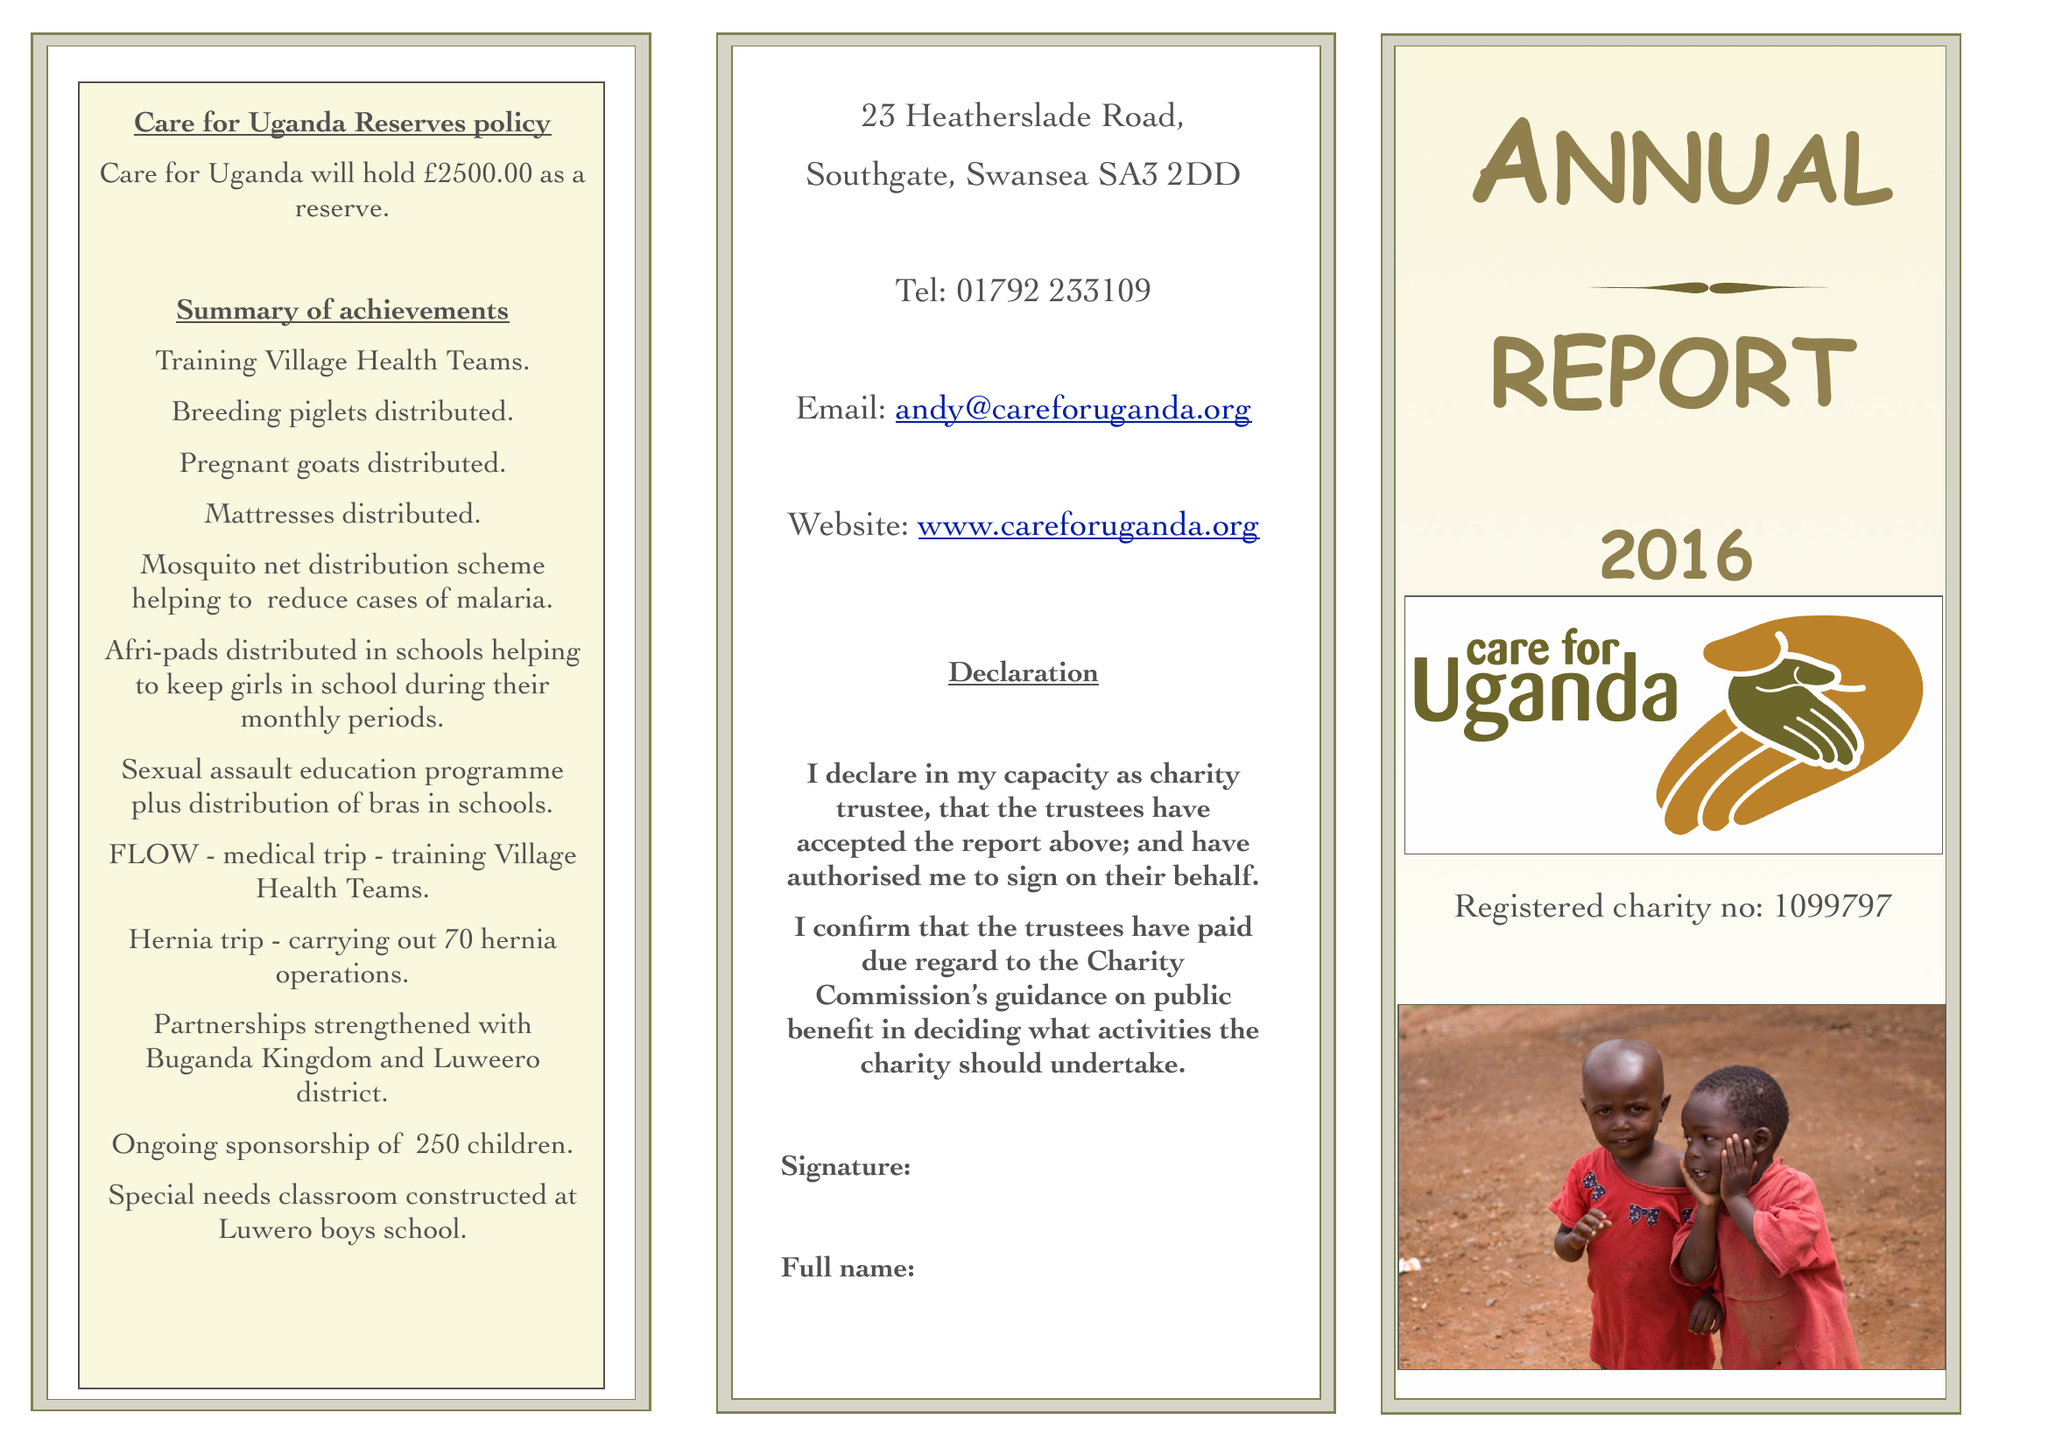What is the value for the charity_name?
Answer the question using a single word or phrase. Care For Uganda 